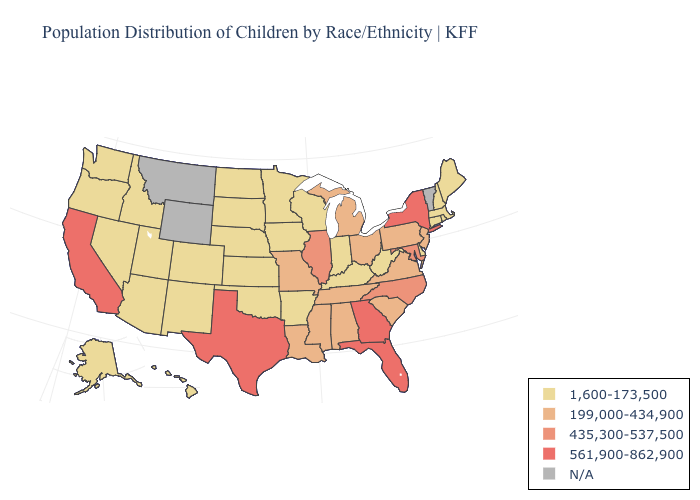What is the value of Montana?
Concise answer only. N/A. Name the states that have a value in the range 561,900-862,900?
Answer briefly. California, Florida, Georgia, New York, Texas. What is the lowest value in the South?
Short answer required. 1,600-173,500. Name the states that have a value in the range N/A?
Short answer required. Montana, Vermont, Wyoming. Name the states that have a value in the range 435,300-537,500?
Keep it brief. Illinois, Maryland, North Carolina. Does Mississippi have the highest value in the USA?
Write a very short answer. No. Name the states that have a value in the range 199,000-434,900?
Concise answer only. Alabama, Louisiana, Michigan, Mississippi, Missouri, New Jersey, Ohio, Pennsylvania, South Carolina, Tennessee, Virginia. Does Missouri have the highest value in the USA?
Answer briefly. No. Which states have the highest value in the USA?
Write a very short answer. California, Florida, Georgia, New York, Texas. What is the lowest value in the USA?
Quick response, please. 1,600-173,500. How many symbols are there in the legend?
Give a very brief answer. 5. Which states have the lowest value in the USA?
Write a very short answer. Alaska, Arizona, Arkansas, Colorado, Connecticut, Delaware, Hawaii, Idaho, Indiana, Iowa, Kansas, Kentucky, Maine, Massachusetts, Minnesota, Nebraska, Nevada, New Hampshire, New Mexico, North Dakota, Oklahoma, Oregon, Rhode Island, South Dakota, Utah, Washington, West Virginia, Wisconsin. Name the states that have a value in the range 561,900-862,900?
Concise answer only. California, Florida, Georgia, New York, Texas. 